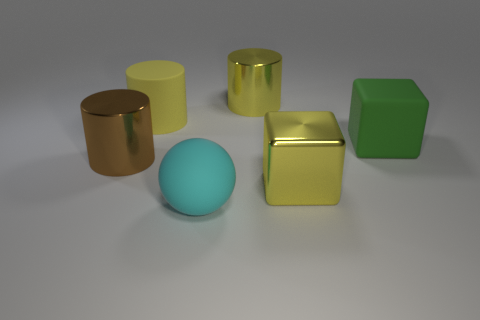What might be the purpose of this image? The image could serve multiple purposes, such as being part of a graphical render test for lighting and texture, a demonstration of 3D modeling capabilities, or an artistic composition focusing on color contrasts and geometric forms. 